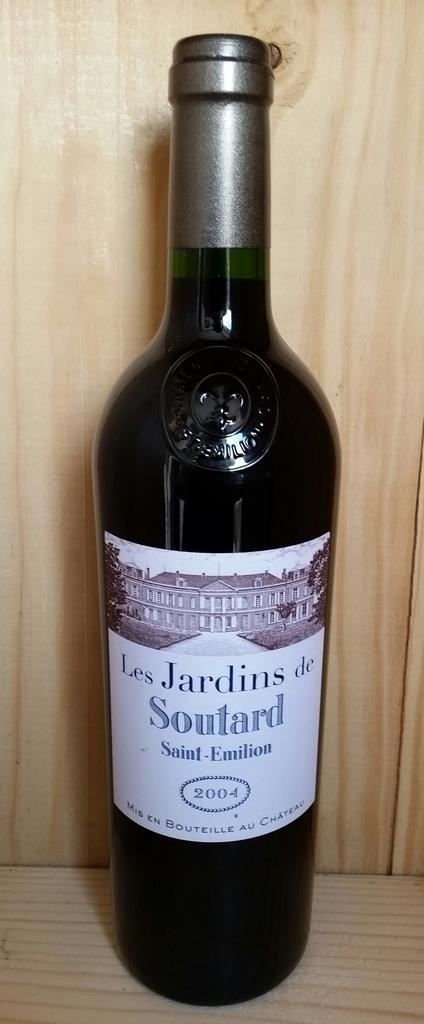<image>
Provide a brief description of the given image. A bottle of wine, from 2004, is labelled Saint-Emilion. 